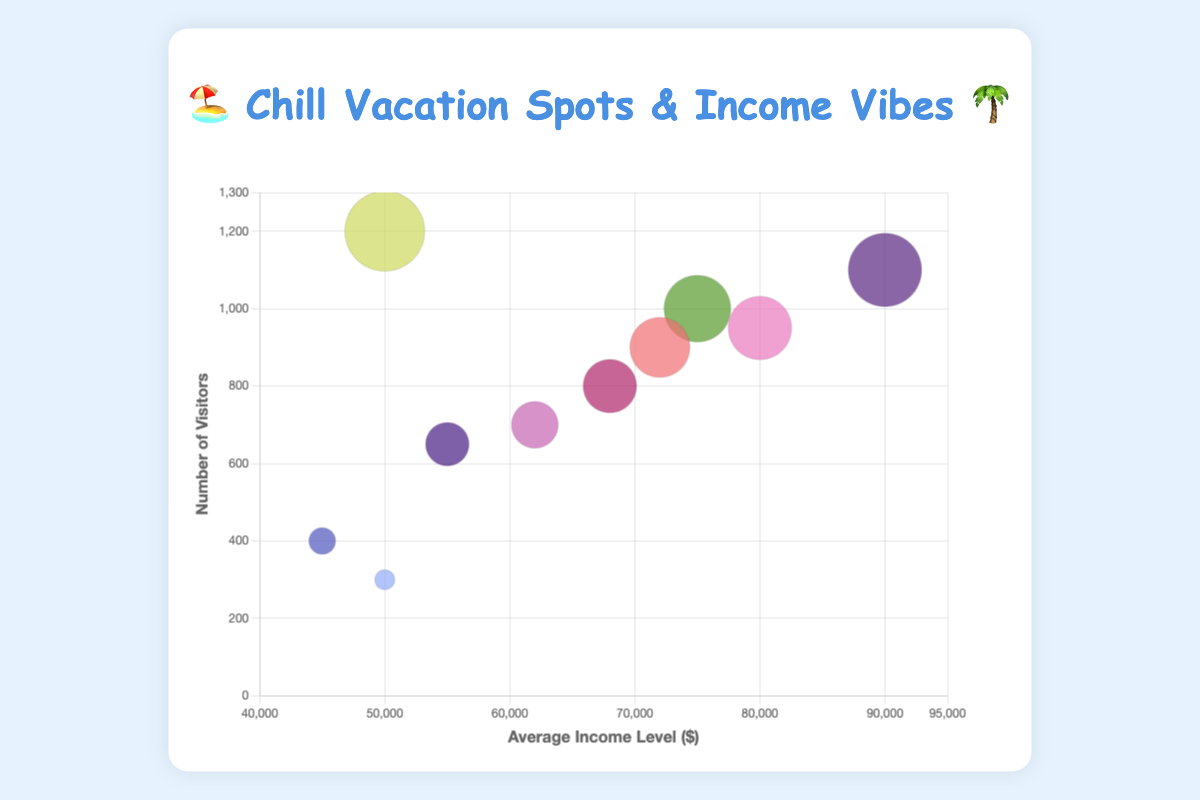Which destination has the highest average income level? Look at the x-axis values to find the data point with the highest x-coordinate. The highest average income level is for New York City.
Answer: New York City What's the number of visitors for Bali? Find the bubble labeled Bali and check the y-coordinate. The number of visitors is 1200.
Answer: 1200 Which destination has a larger number of visitors: Tokyo or Barcelona? Compare the y-coordinates of the bubbles labeled Tokyo and Barcelona. Tokyo has 800 visitors, while Barcelona has 650.
Answer: Tokyo Is there a destination with an average income level of $50000 and how many visitors does it have? Check the x-axis for $50000 and look at the corresponding bubbles. Bali and Santorini both have an average income level of $50000. Bali has 1200 visitors and Santorini has 300. Both destinations need to be included in the answer.
Answer: Bali: 1200, Santorini: 300 How many destinations have an average income level greater than $70000? Find the bubbles with x-coordinates greater than $70000. The destinations are Paris, New York City, Sydney, and Hawaii, totaling four.
Answer: 4 Which destination has the smallest bubble and what does that indicate? Find the smallest bubble and check its label. The smallest bubble corresponds to Santorini, indicating it has the fewest visitors, which is 300.
Answer: Santorini What is the combined number of visitors for destinations with average income levels below $60000? Sum the visitors for bubbles with x-coordinates less than $60000: Bali (1200), Barcelona (650), Cape Town (400), and Santorini (300). 1200 + 650 + 400 + 300 = 2550
Answer: 2550 Which destination falls approximately in the middle in terms of the number of visitors? Arrange the destinations based on the y-coordinate (number of visitors) in ascending order. Find the middle point. The middle destination is Sydney with 900 visitors.
Answer: Sydney Do any destinations have both an average income level below $55000 and fewer than 500 visitors? Check for bubbles with x-coordinates less than $55000 and y-coordinates less than 500. Cape Town fits this criterion.
Answer: Cape Town What is the average number of visitors for destinations with an average income level above $70000? Identify the bubbles with x-coordinates greater than $70000: Paris (1000), New York City (1100), Hawaii (950), Sydney (900). Calculate the average: (1000 + 1100 + 950 + 900) / 4 = 987.5
Answer: 987.5 